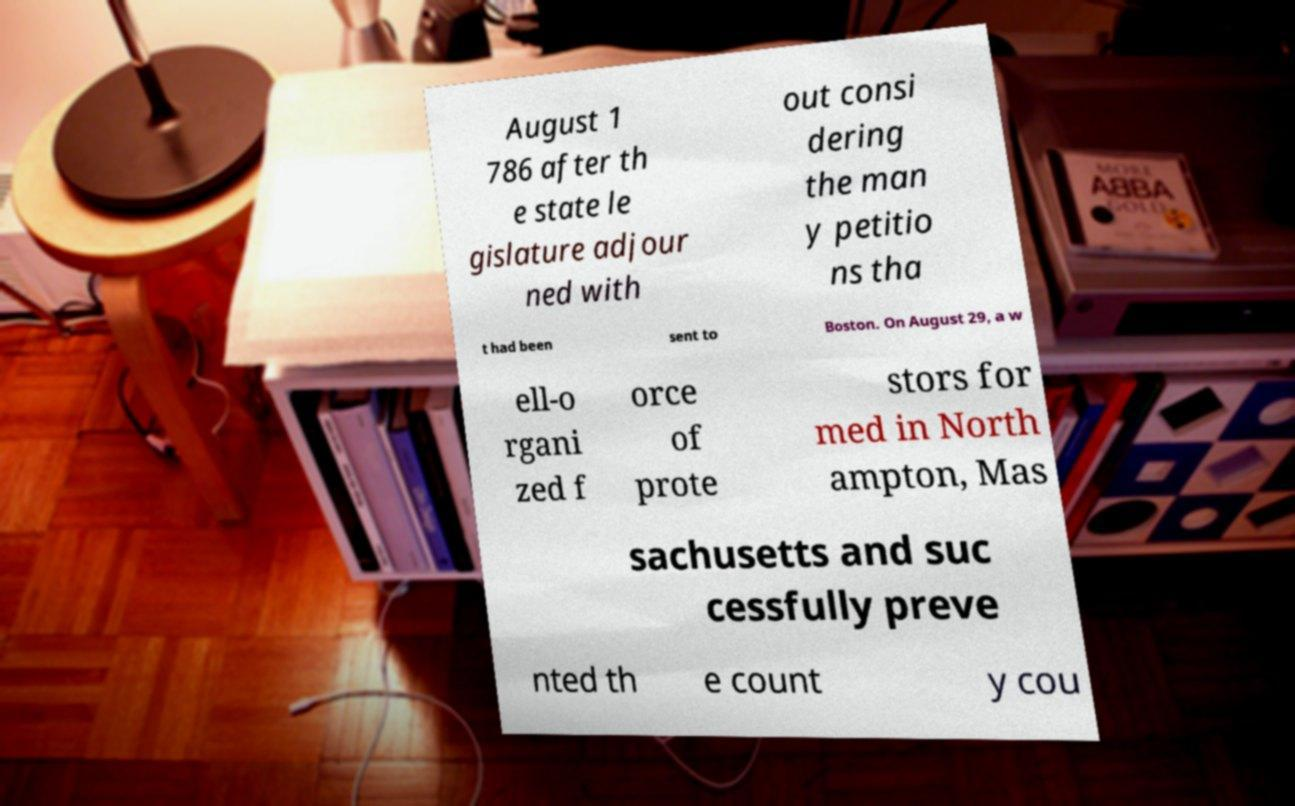For documentation purposes, I need the text within this image transcribed. Could you provide that? August 1 786 after th e state le gislature adjour ned with out consi dering the man y petitio ns tha t had been sent to Boston. On August 29, a w ell-o rgani zed f orce of prote stors for med in North ampton, Mas sachusetts and suc cessfully preve nted th e count y cou 